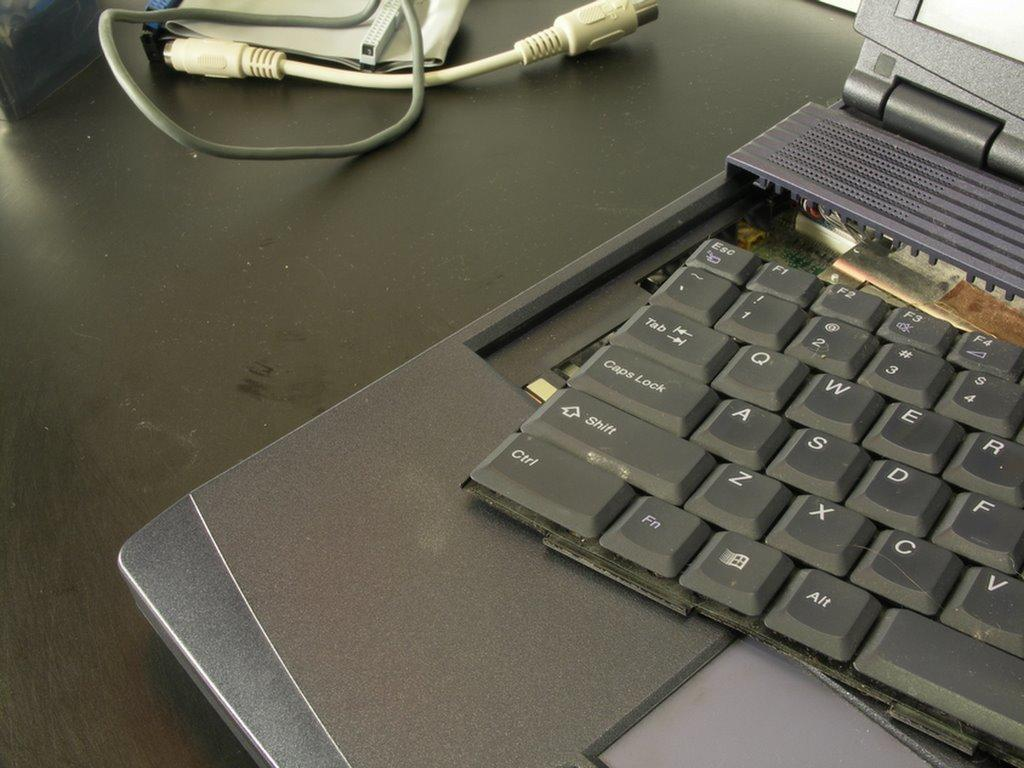<image>
Summarize the visual content of the image. a QWERTY style keyboard is removed from a laptop computer for repair. 